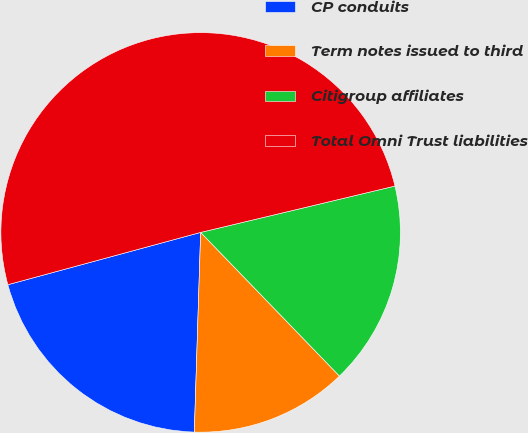Convert chart to OTSL. <chart><loc_0><loc_0><loc_500><loc_500><pie_chart><fcel>CP conduits<fcel>Term notes issued to third<fcel>Citigroup affiliates<fcel>Total Omni Trust liabilities<nl><fcel>20.28%<fcel>12.73%<fcel>16.5%<fcel>50.49%<nl></chart> 